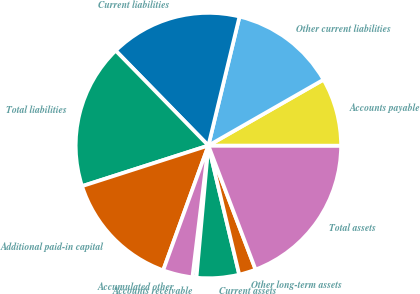Convert chart. <chart><loc_0><loc_0><loc_500><loc_500><pie_chart><fcel>Accounts receivable<fcel>Current assets<fcel>Other long-term assets<fcel>Total assets<fcel>Accounts payable<fcel>Other current liabilities<fcel>Current liabilities<fcel>Total liabilities<fcel>Additional paid-in capital<fcel>Accumulated other<nl><fcel>0.49%<fcel>5.17%<fcel>2.05%<fcel>19.2%<fcel>8.29%<fcel>12.96%<fcel>16.08%<fcel>17.64%<fcel>14.52%<fcel>3.61%<nl></chart> 